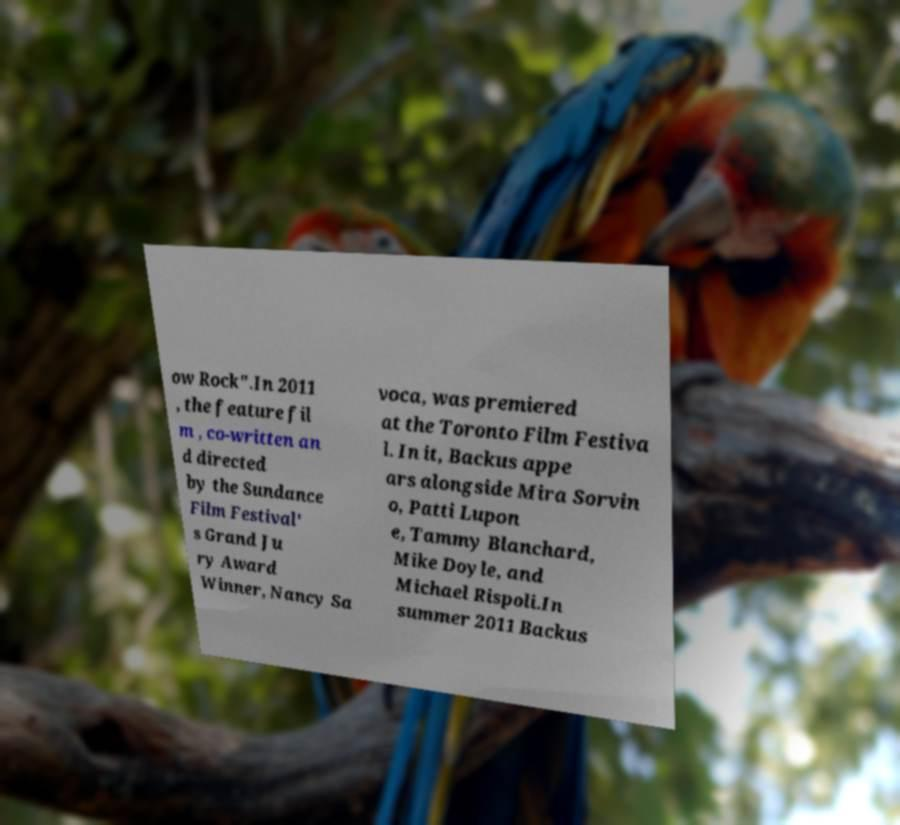What messages or text are displayed in this image? I need them in a readable, typed format. ow Rock".In 2011 , the feature fil m , co-written an d directed by the Sundance Film Festival' s Grand Ju ry Award Winner, Nancy Sa voca, was premiered at the Toronto Film Festiva l. In it, Backus appe ars alongside Mira Sorvin o, Patti Lupon e, Tammy Blanchard, Mike Doyle, and Michael Rispoli.In summer 2011 Backus 